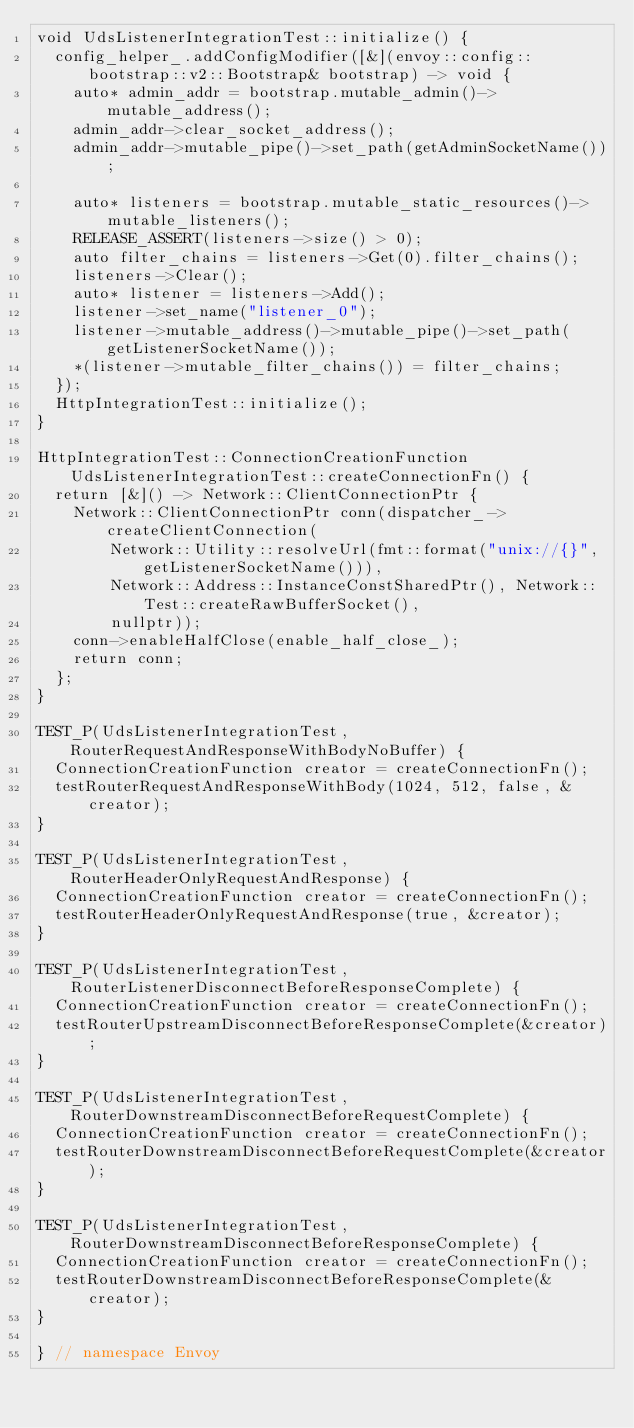<code> <loc_0><loc_0><loc_500><loc_500><_C++_>void UdsListenerIntegrationTest::initialize() {
  config_helper_.addConfigModifier([&](envoy::config::bootstrap::v2::Bootstrap& bootstrap) -> void {
    auto* admin_addr = bootstrap.mutable_admin()->mutable_address();
    admin_addr->clear_socket_address();
    admin_addr->mutable_pipe()->set_path(getAdminSocketName());

    auto* listeners = bootstrap.mutable_static_resources()->mutable_listeners();
    RELEASE_ASSERT(listeners->size() > 0);
    auto filter_chains = listeners->Get(0).filter_chains();
    listeners->Clear();
    auto* listener = listeners->Add();
    listener->set_name("listener_0");
    listener->mutable_address()->mutable_pipe()->set_path(getListenerSocketName());
    *(listener->mutable_filter_chains()) = filter_chains;
  });
  HttpIntegrationTest::initialize();
}

HttpIntegrationTest::ConnectionCreationFunction UdsListenerIntegrationTest::createConnectionFn() {
  return [&]() -> Network::ClientConnectionPtr {
    Network::ClientConnectionPtr conn(dispatcher_->createClientConnection(
        Network::Utility::resolveUrl(fmt::format("unix://{}", getListenerSocketName())),
        Network::Address::InstanceConstSharedPtr(), Network::Test::createRawBufferSocket(),
        nullptr));
    conn->enableHalfClose(enable_half_close_);
    return conn;
  };
}

TEST_P(UdsListenerIntegrationTest, RouterRequestAndResponseWithBodyNoBuffer) {
  ConnectionCreationFunction creator = createConnectionFn();
  testRouterRequestAndResponseWithBody(1024, 512, false, &creator);
}

TEST_P(UdsListenerIntegrationTest, RouterHeaderOnlyRequestAndResponse) {
  ConnectionCreationFunction creator = createConnectionFn();
  testRouterHeaderOnlyRequestAndResponse(true, &creator);
}

TEST_P(UdsListenerIntegrationTest, RouterListenerDisconnectBeforeResponseComplete) {
  ConnectionCreationFunction creator = createConnectionFn();
  testRouterUpstreamDisconnectBeforeResponseComplete(&creator);
}

TEST_P(UdsListenerIntegrationTest, RouterDownstreamDisconnectBeforeRequestComplete) {
  ConnectionCreationFunction creator = createConnectionFn();
  testRouterDownstreamDisconnectBeforeRequestComplete(&creator);
}

TEST_P(UdsListenerIntegrationTest, RouterDownstreamDisconnectBeforeResponseComplete) {
  ConnectionCreationFunction creator = createConnectionFn();
  testRouterDownstreamDisconnectBeforeResponseComplete(&creator);
}

} // namespace Envoy
</code> 